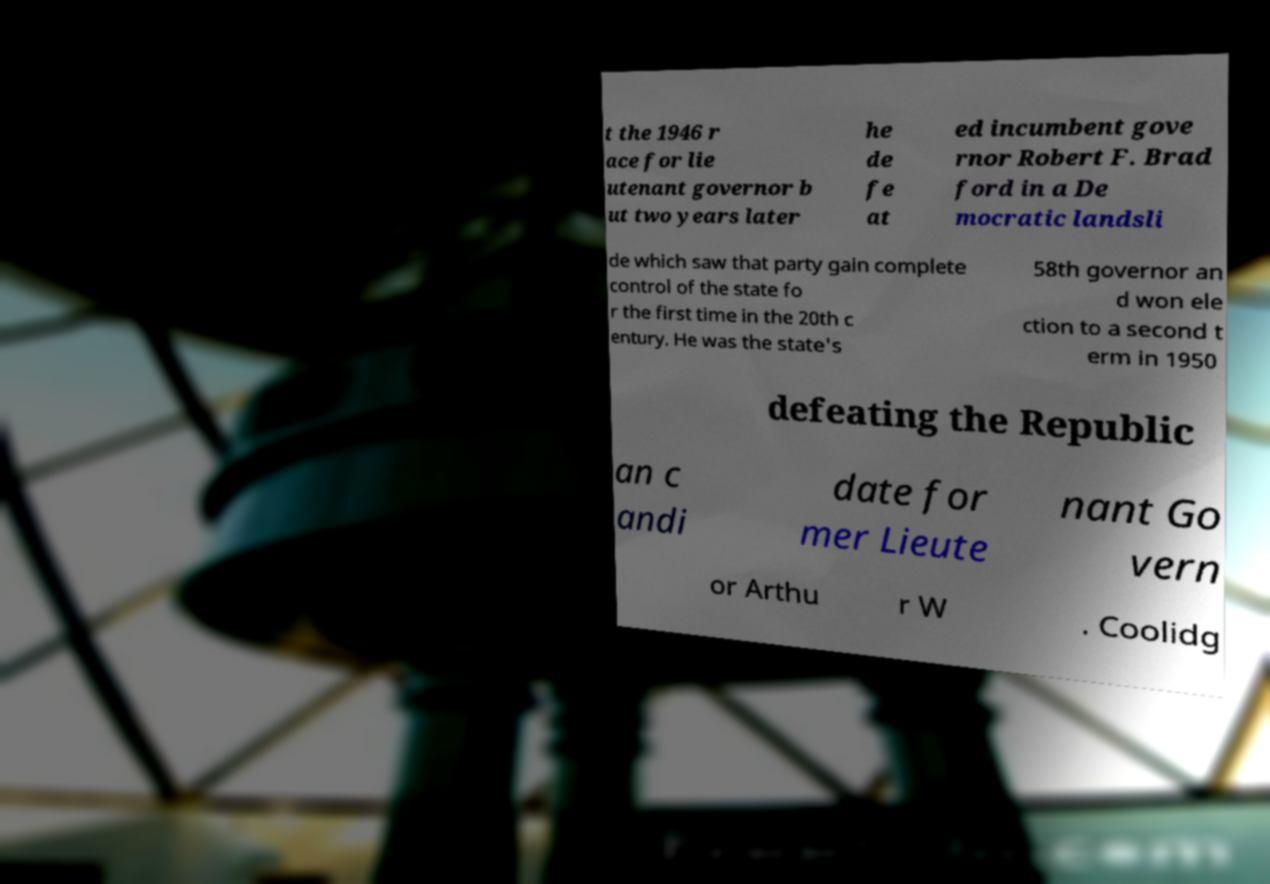I need the written content from this picture converted into text. Can you do that? t the 1946 r ace for lie utenant governor b ut two years later he de fe at ed incumbent gove rnor Robert F. Brad ford in a De mocratic landsli de which saw that party gain complete control of the state fo r the first time in the 20th c entury. He was the state's 58th governor an d won ele ction to a second t erm in 1950 defeating the Republic an c andi date for mer Lieute nant Go vern or Arthu r W . Coolidg 